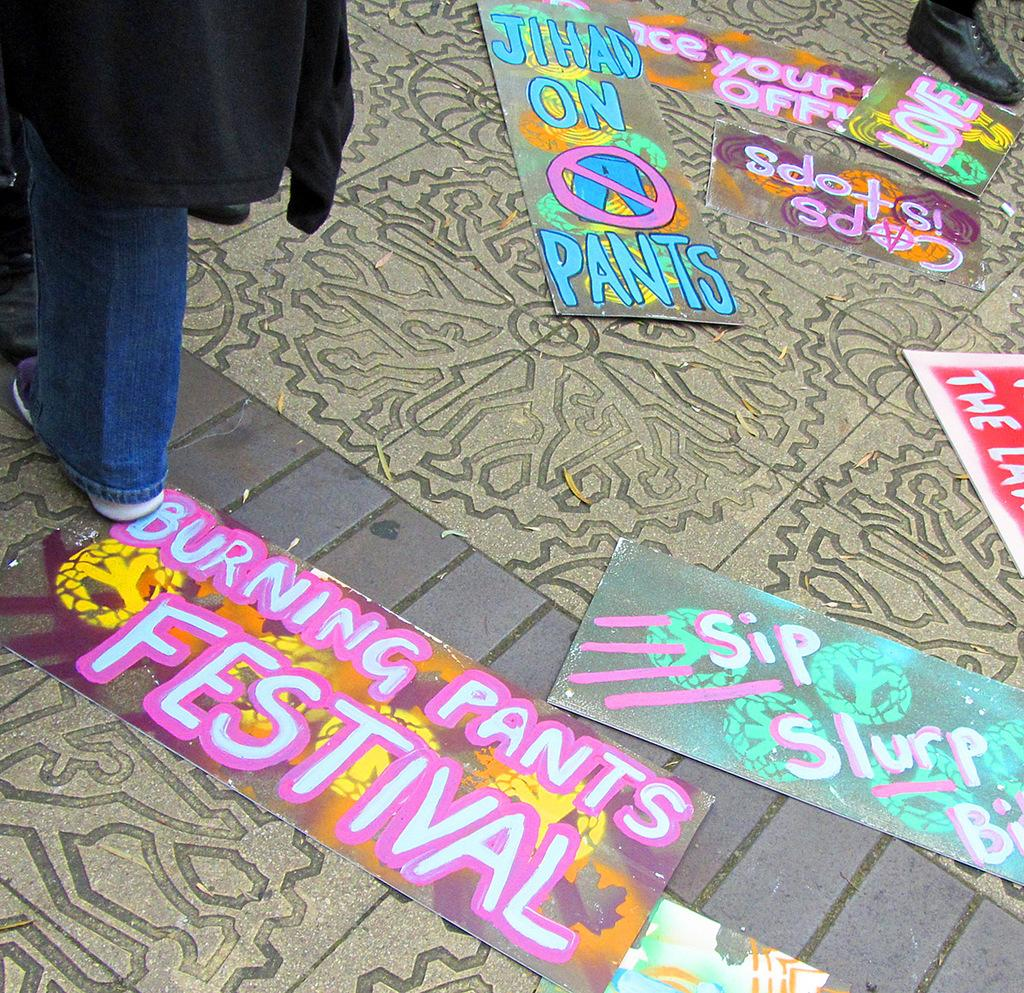What is on the floor in the image? There are painted papers on the floor in the image. Can you describe the woman in the image? There is a woman on the left side of the image. What rule is the woman enforcing in the image? There is no indication in the image that the woman is enforcing any rules. Can you describe the house in the image? There is no house present in the image; it only features painted papers on the floor and a woman on the left side. 